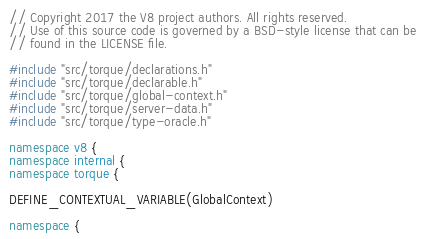<code> <loc_0><loc_0><loc_500><loc_500><_C++_>// Copyright 2017 the V8 project authors. All rights reserved.
// Use of this source code is governed by a BSD-style license that can be
// found in the LICENSE file.

#include "src/torque/declarations.h"
#include "src/torque/declarable.h"
#include "src/torque/global-context.h"
#include "src/torque/server-data.h"
#include "src/torque/type-oracle.h"

namespace v8 {
namespace internal {
namespace torque {

DEFINE_CONTEXTUAL_VARIABLE(GlobalContext)

namespace {
</code> 